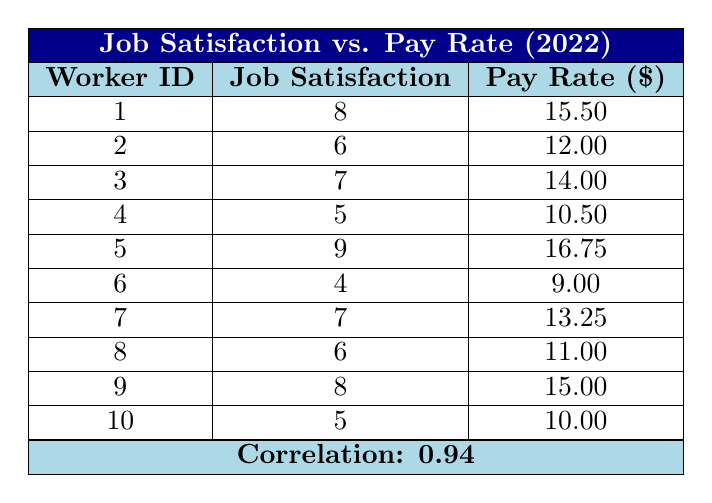What is the highest job satisfaction score recorded in the table? The highest job satisfaction score can be found by checking all the values in that column. The scores are 8, 6, 7, 5, 9, 4, 7, 6, 8, and 5, and the highest among them is 9.
Answer: 9 Which worker has the lowest pay rate? To find the lowest pay rate, we need to look at the Pay Rate column and identify the smallest value. The rates are 15.50, 12.00, 14.00, 10.50, 16.75, 9.00, 13.25, 11.00, 15.00, and 10.00. The lowest value is 9.00, which corresponds to Worker_ID 6.
Answer: 9.00 Is it true that all workers with a job satisfaction score of 7 or above have a pay rate higher than 12.00? We check the workers with job satisfaction scores of 7 or above, which are Workers 1, 3, 5, 7, and 9. Their pay rates are 15.50, 14.00, 16.75, 13.25, and 15.00, all of which are indeed higher than 12.00. Thus, the statement is true.
Answer: Yes What is the average pay rate of workers with a job satisfaction score of 6 or lower? First, we identify the workers with job satisfaction scores of 6 or lower: Workers 2, 4, 6, 8, and 10. Their pay rates are 12.00, 10.50, 9.00, 11.00, and 10.00, respectively. The total pay rate sums to (12.00 + 10.50 + 9.00 + 11.00 + 10.00) = 52.50. There are 5 workers, so the average pay rate is 52.50 / 5 = 10.50.
Answer: 10.50 How many workers have a pay rate of $15 or more? We check the Pay Rate column for values equal to or greater than $15. The pay rates are 15.50, 16.75, 15.00. The corresponding Worker IDs are 1, 5, and 9, making a total of 3 workers.
Answer: 3 